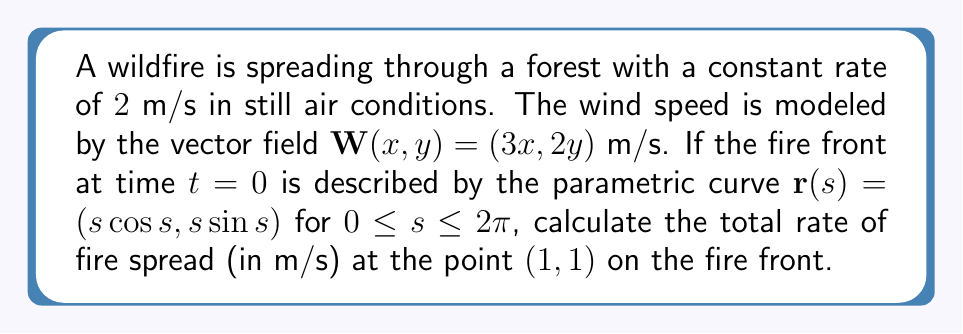Solve this math problem. To solve this problem, we'll follow these steps:

1) The fire spread vector $\mathbf{F}$ is composed of two parts:
   a) The spread in still air conditions ($2$ m/s in the direction normal to the fire front)
   b) The additional spread due to wind

2) To find the normal vector to the fire front at $(1, 1)$, we need to:
   a) Calculate $\mathbf{r}'(s)$
   b) Find the parameter $s$ for the point $(1, 1)$
   c) Calculate the unit normal vector

3) Calculate the wind vector at $(1, 1)$

4) Combine the still air spread and wind effect to get the total spread vector

Step 1: The fire spread vector will be $\mathbf{F} = 2\mathbf{n} + \mathbf{W}$, where $\mathbf{n}$ is the unit normal vector to the fire front.

Step 2a: $\mathbf{r}'(s) = (\cos s - s\sin s, \sin s + s\cos s)$

Step 2b: At $(1, 1)$, $s = \frac{\pi}{4}$ (because $\cos \frac{\pi}{4} = \sin \frac{\pi}{4} = \frac{1}{\sqrt{2}}$)

Step 2c: The normal vector is perpendicular to the tangent vector $\mathbf{r}'(\frac{\pi}{4})$:
$\mathbf{n} = \frac{(\sin \frac{\pi}{4} + \frac{\pi}{4}\cos \frac{\pi}{4}, -\cos \frac{\pi}{4} + \frac{\pi}{4}\sin \frac{\pi}{4})}{\sqrt{(\sin \frac{\pi}{4} + \frac{\pi}{4}\cos \frac{\pi}{4})^2 + (-\cos \frac{\pi}{4} + \frac{\pi}{4}\sin \frac{\pi}{4})^2}}$

Step 3: $\mathbf{W}(1, 1) = (3, 2)$ m/s

Step 4: $\mathbf{F} = 2\mathbf{n} + (3, 2)$

The magnitude of this vector gives the total rate of fire spread:

$\|\mathbf{F}\| = \sqrt{(2n_x + 3)^2 + (2n_y + 2)^2}$ m/s

Where $n_x$ and $n_y$ are the components of the unit normal vector $\mathbf{n}$.
Answer: $\sqrt{(2n_x + 3)^2 + (2n_y + 2)^2}$ m/s, where $n_x$ and $n_y$ are components of the unit normal vector at $(1, 1)$ 